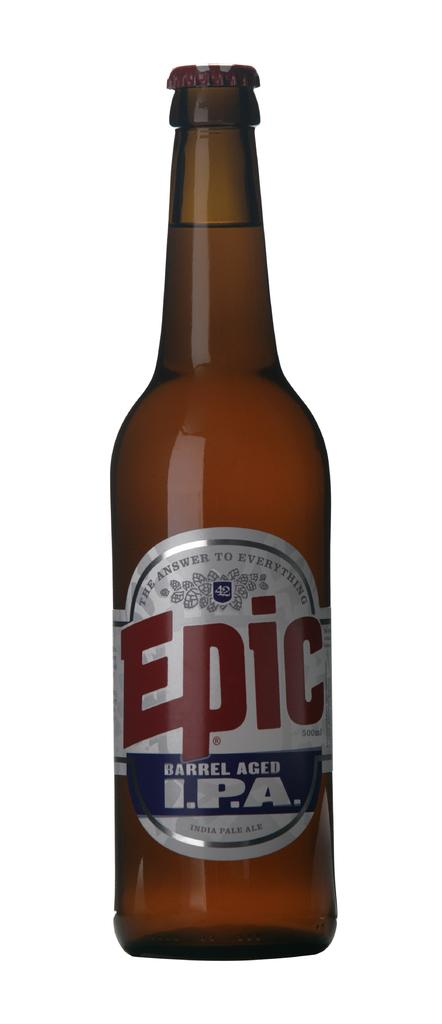<image>
Describe the image concisely. A beer bottle with a label on it named Epic. 